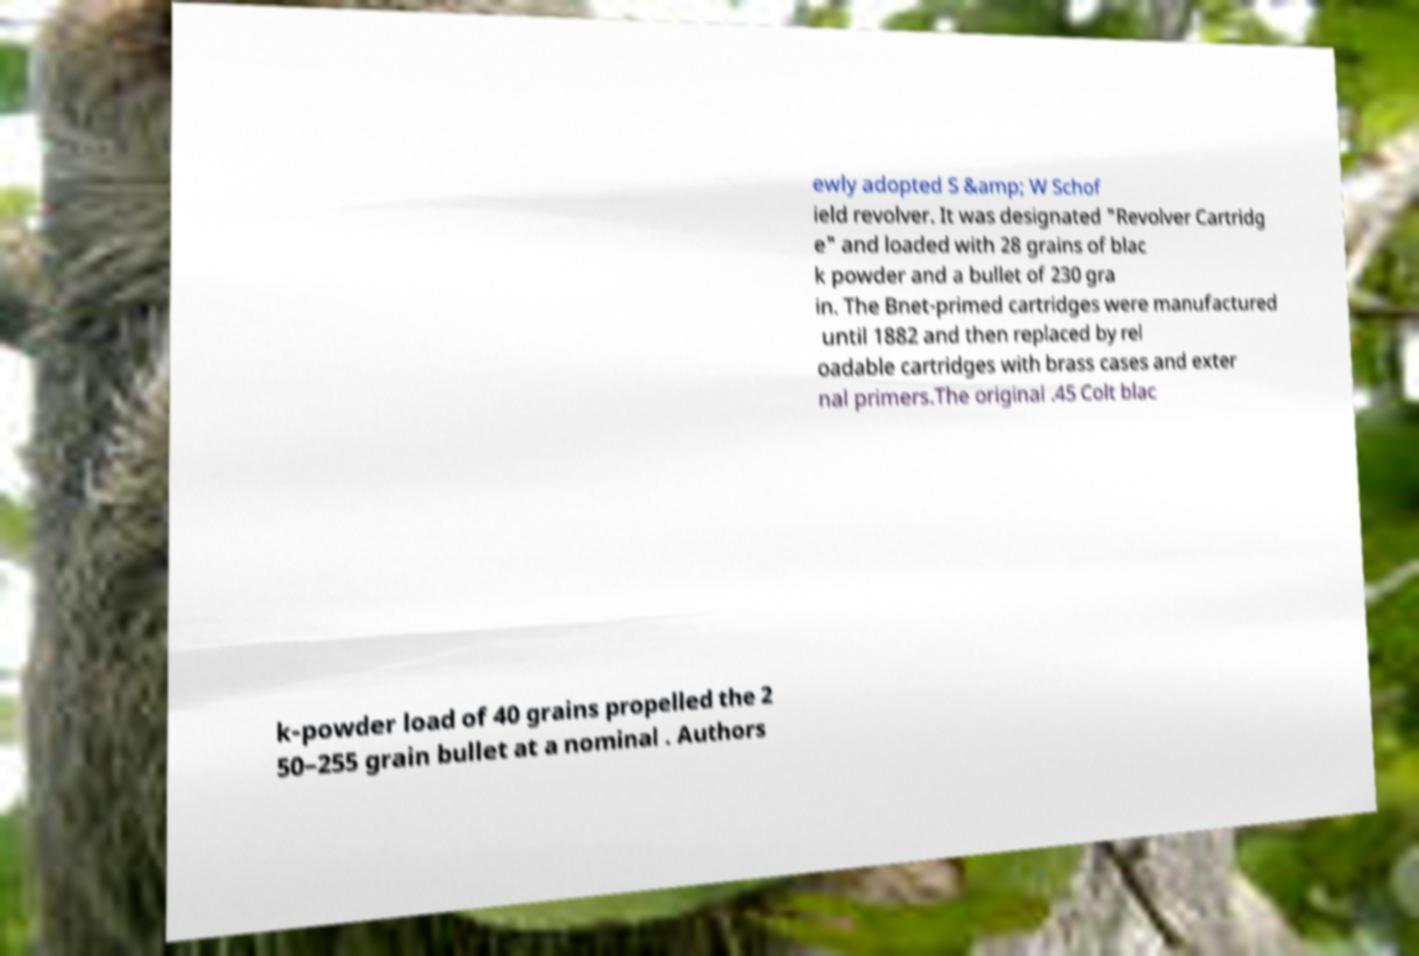Please read and relay the text visible in this image. What does it say? ewly adopted S &amp; W Schof ield revolver. It was designated "Revolver Cartridg e" and loaded with 28 grains of blac k powder and a bullet of 230 gra in. The Bnet-primed cartridges were manufactured until 1882 and then replaced by rel oadable cartridges with brass cases and exter nal primers.The original .45 Colt blac k-powder load of 40 grains propelled the 2 50–255 grain bullet at a nominal . Authors 